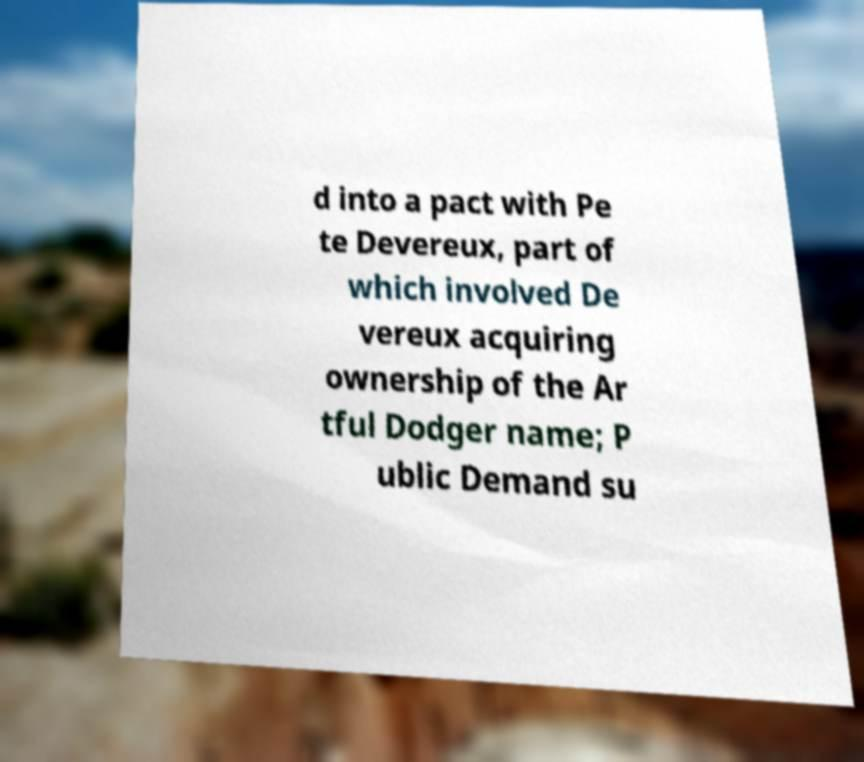Could you extract and type out the text from this image? d into a pact with Pe te Devereux, part of which involved De vereux acquiring ownership of the Ar tful Dodger name; P ublic Demand su 